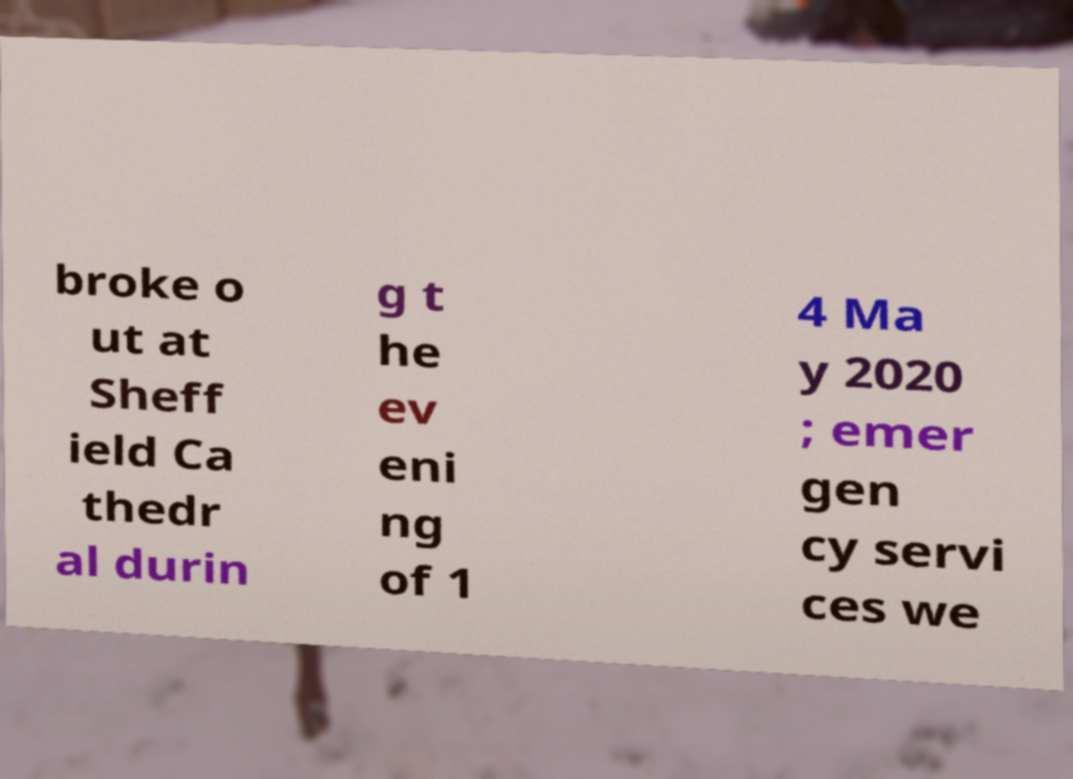Can you read and provide the text displayed in the image?This photo seems to have some interesting text. Can you extract and type it out for me? broke o ut at Sheff ield Ca thedr al durin g t he ev eni ng of 1 4 Ma y 2020 ; emer gen cy servi ces we 